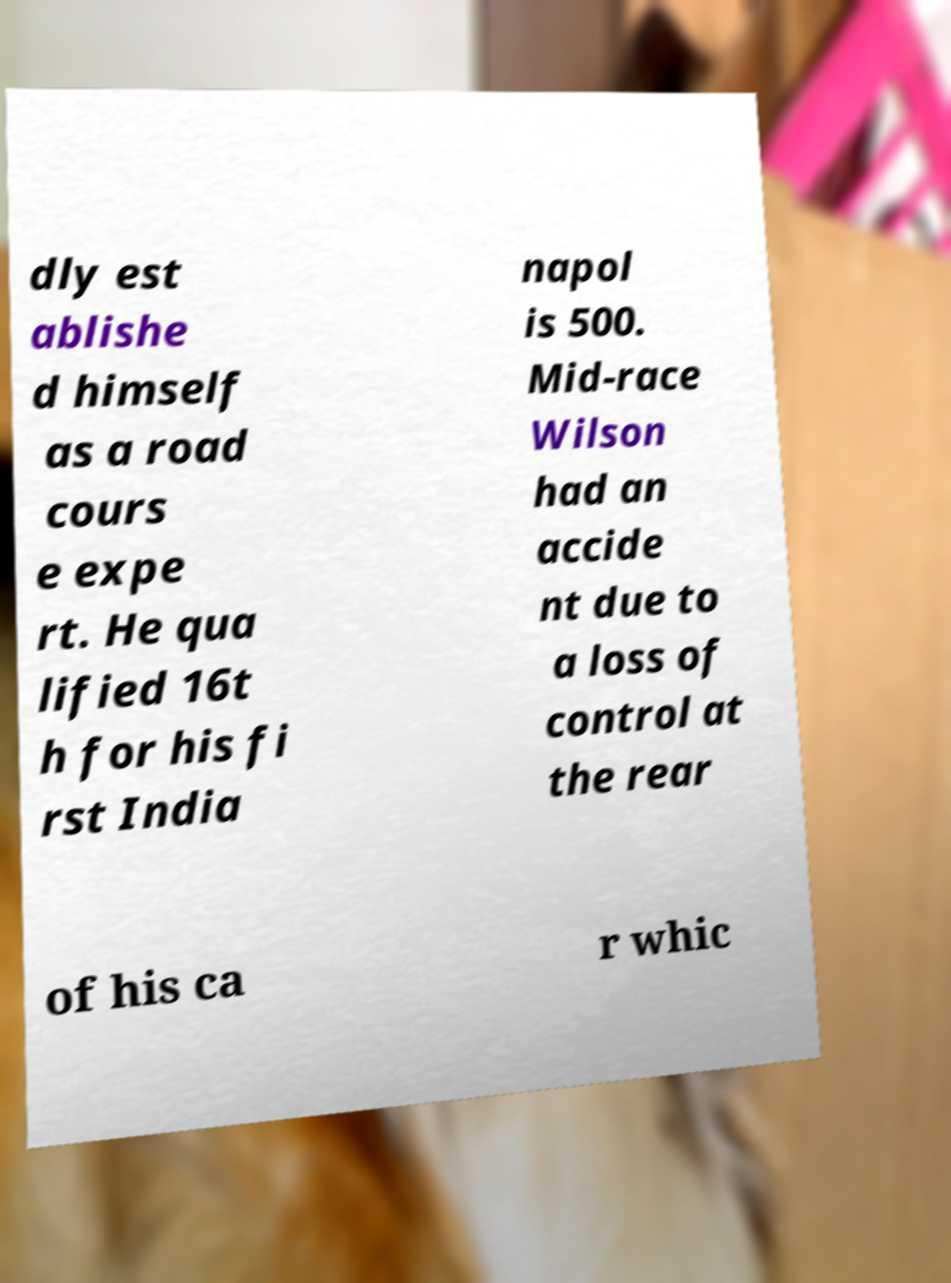I need the written content from this picture converted into text. Can you do that? dly est ablishe d himself as a road cours e expe rt. He qua lified 16t h for his fi rst India napol is 500. Mid-race Wilson had an accide nt due to a loss of control at the rear of his ca r whic 